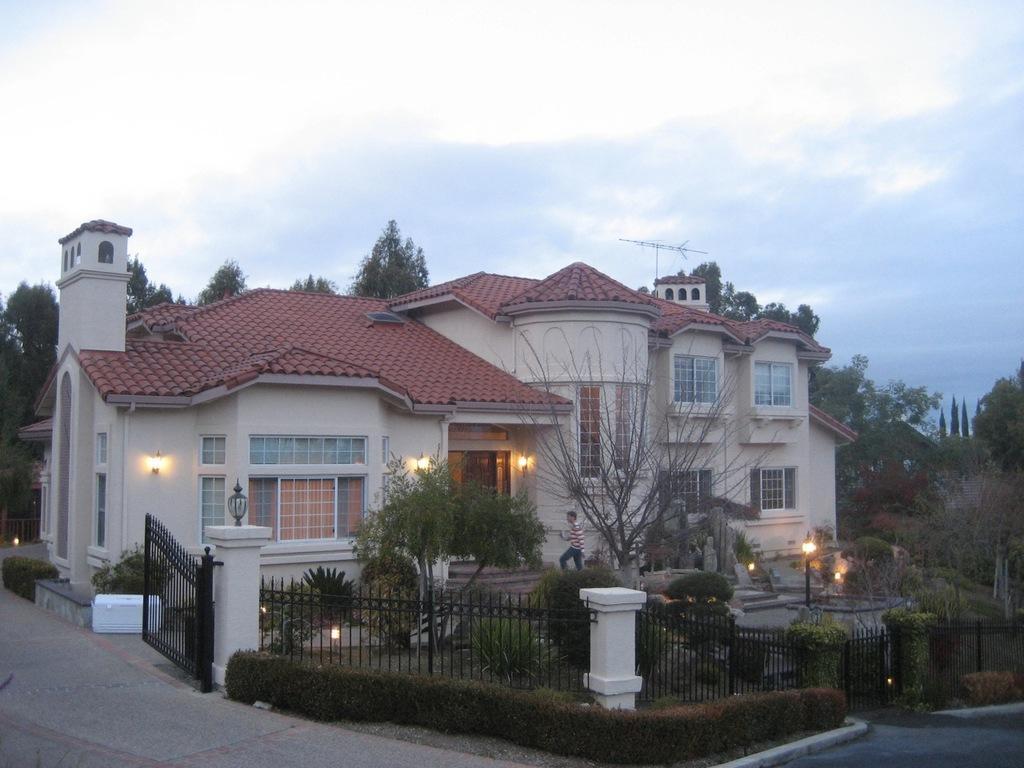Describe this image in one or two sentences. In the center of the image there is a building. At the bottom there is a road, fence and a gate. There is a person walking. We can see stars there are trees, lights and sky. 